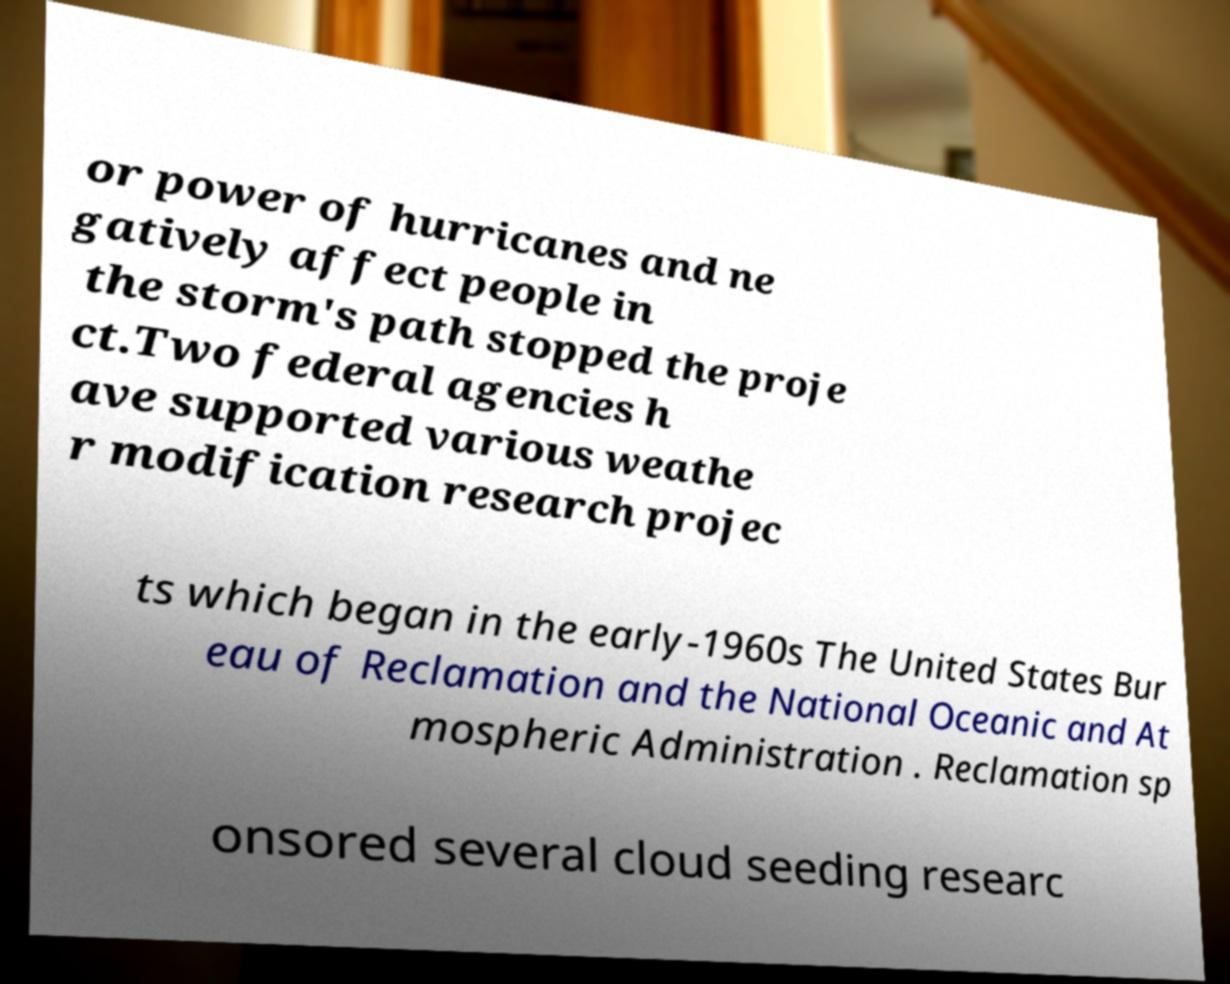Please identify and transcribe the text found in this image. or power of hurricanes and ne gatively affect people in the storm's path stopped the proje ct.Two federal agencies h ave supported various weathe r modification research projec ts which began in the early-1960s The United States Bur eau of Reclamation and the National Oceanic and At mospheric Administration . Reclamation sp onsored several cloud seeding researc 